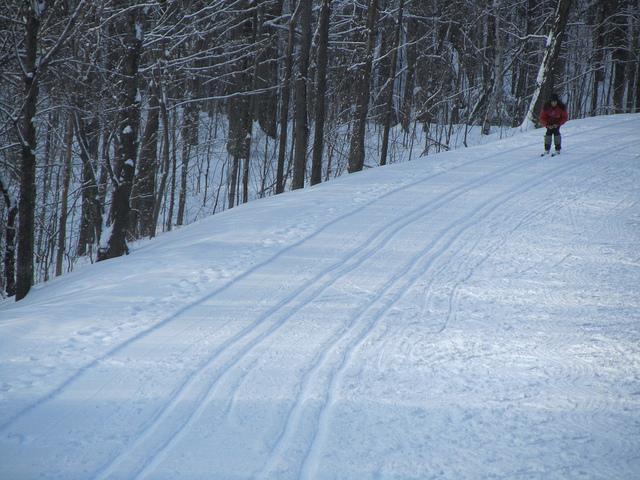How many people are going downhill?
Give a very brief answer. 1. How many umbrellas are there?
Give a very brief answer. 0. 